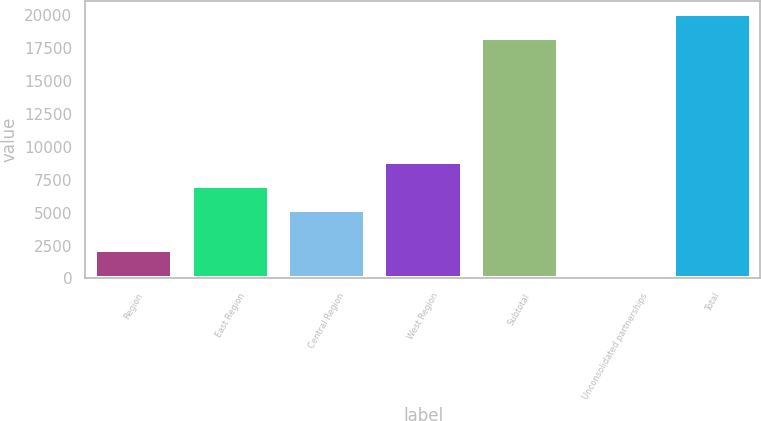Convert chart to OTSL. <chart><loc_0><loc_0><loc_500><loc_500><bar_chart><fcel>Region<fcel>East Region<fcel>Central Region<fcel>West Region<fcel>Subtotal<fcel>Unconsolidated partnerships<fcel>Total<nl><fcel>2165.6<fcel>7026.6<fcel>5203<fcel>8850.2<fcel>18236<fcel>342<fcel>20059.6<nl></chart> 